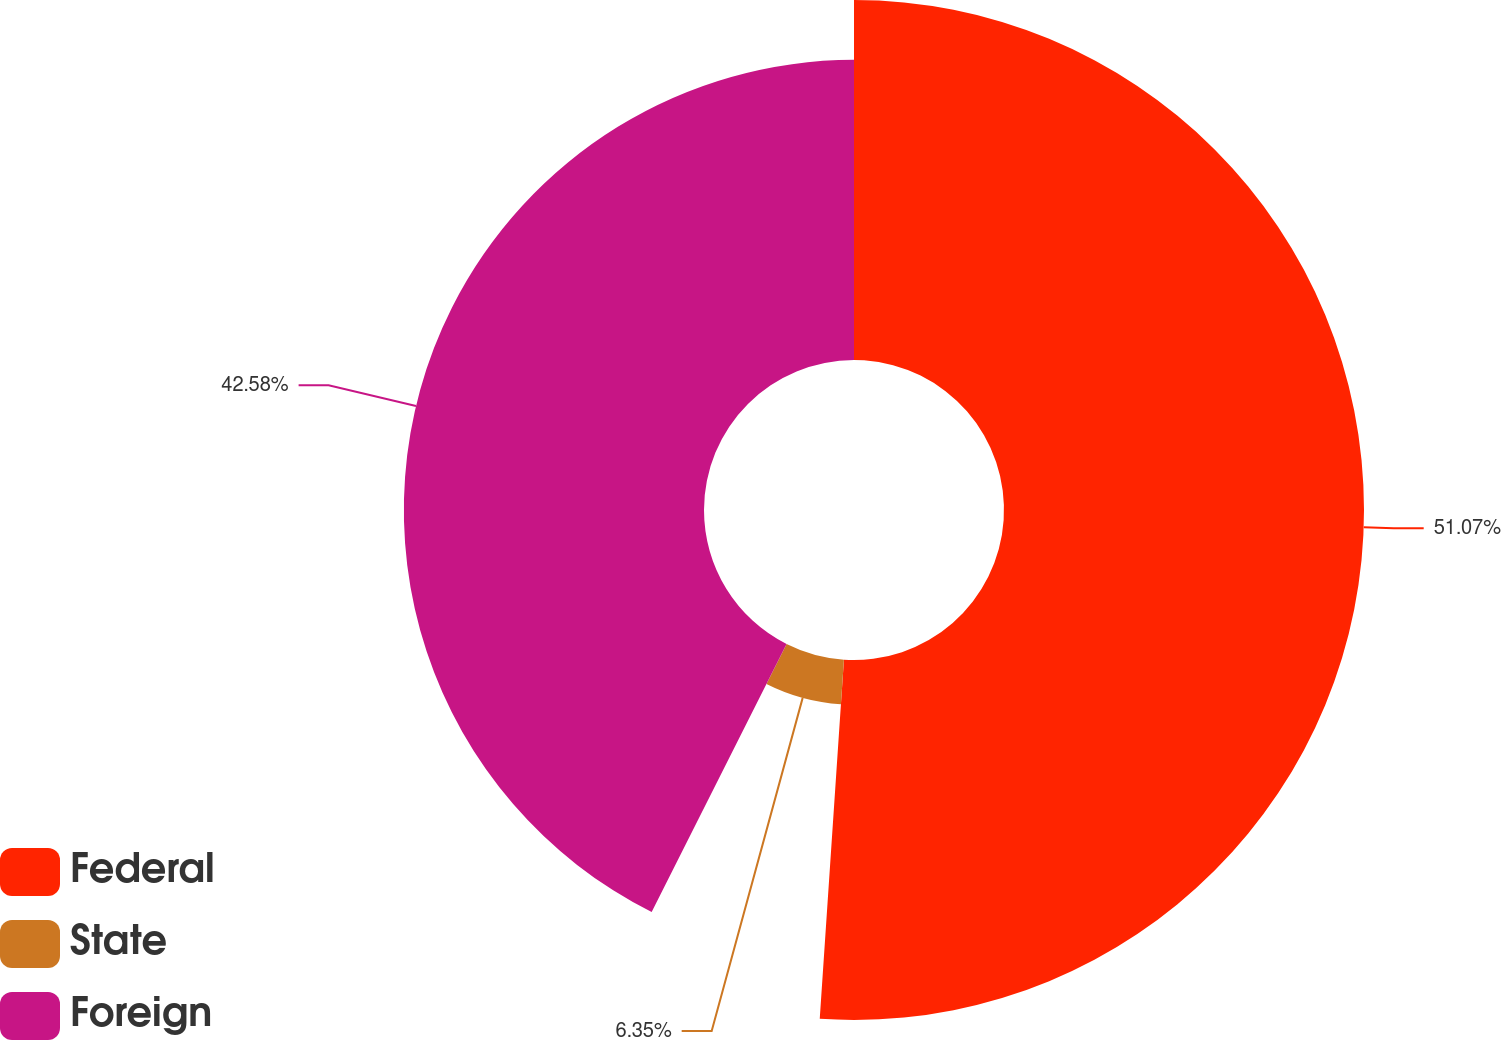Convert chart to OTSL. <chart><loc_0><loc_0><loc_500><loc_500><pie_chart><fcel>Federal<fcel>State<fcel>Foreign<nl><fcel>51.07%<fcel>6.35%<fcel>42.58%<nl></chart> 